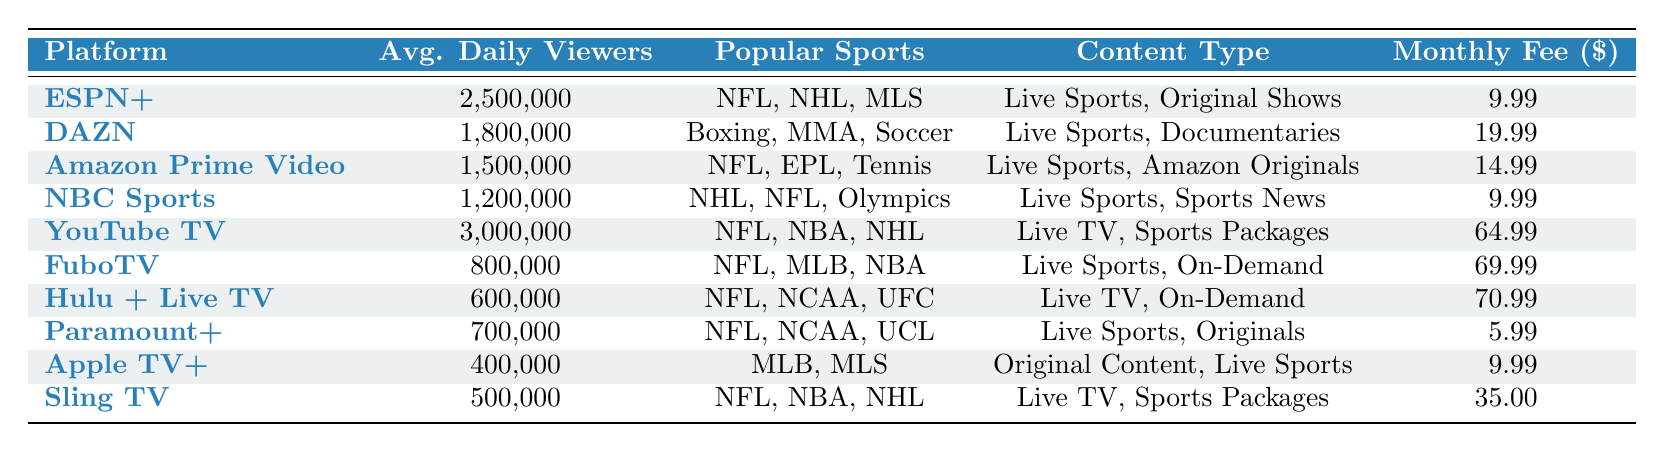What is the platform with the highest average daily viewers? By looking at the "Avg. Daily Viewers" column, we can see that YouTube TV has the highest number at 3,000,000 viewers.
Answer: YouTube TV Which platform has the lowest monthly subscription fee? The "Monthly Fee" column shows that Paramount+ has the lowest fee at $5.99.
Answer: Paramount+ How many total average daily viewers do ESPN+ and DAZN combined have? Adding the average daily viewers of ESPN+ (2,500,000) and DAZN (1,800,000) gives us a total of 2,500,000 + 1,800,000 = 4,300,000 viewers.
Answer: 4,300,000 Is it true that Hulu + Live TV has more average daily viewers than FuboTV? Comparing the average daily viewers, Hulu + Live TV has 600,000 and FuboTV has 800,000, so the statement is false.
Answer: No What are the total average daily viewers for platforms that feature NFL? The platforms featuring NFL are ESPN+ (2,500,000), Amazon Prime Video (1,500,000), NBC Sports (1,200,000), YouTube TV (3,000,000), FuboTV (800,000), Hulu + Live TV (600,000), Paramount+ (700,000), and Sling TV (500,000). Adding these gives us 2,500,000 + 1,500,000 + 1,200,000 + 3,000,000 + 800,000 + 600,000 + 700,000 + 500,000 = 12,800,000 viewers.
Answer: 12,800,000 How much higher is the average daily viewership of YouTube TV compared to Paramount+? The average daily viewers for YouTube TV is 3,000,000, while for Paramount+, it is 700,000. The difference is 3,000,000 - 700,000 = 2,300,000 viewers.
Answer: 2,300,000 Which platforms have an average daily viewership of over 1,000,000? The platforms with over 1,000,000 viewers are YouTube TV (3,000,000), ESPN+ (2,500,000), DAZN (1,800,000), Amazon Prime Video (1,500,000), and NBC Sports (1,200,000).
Answer: YouTube TV, ESPN+, DAZN, Amazon Prime Video, NBC Sports What is the average monthly subscription fee of all platforms listed? First, we add the monthly fees: 9.99 + 19.99 + 14.99 + 9.99 + 64.99 + 69.99 + 70.99 + 5.99 + 9.99 + 35.00 = 320.90. We then divide by 10 platforms: 320.90 / 10 = 32.09.
Answer: 32.09 Does any platform offer both live sports and original shows at a subscription fee below $10? Checking the platforms, ESPN+ offers live sports and original shows at a fee of $9.99. However, all other platforms either do not offer both or charge more than $10. Thus the answer is yes.
Answer: Yes 